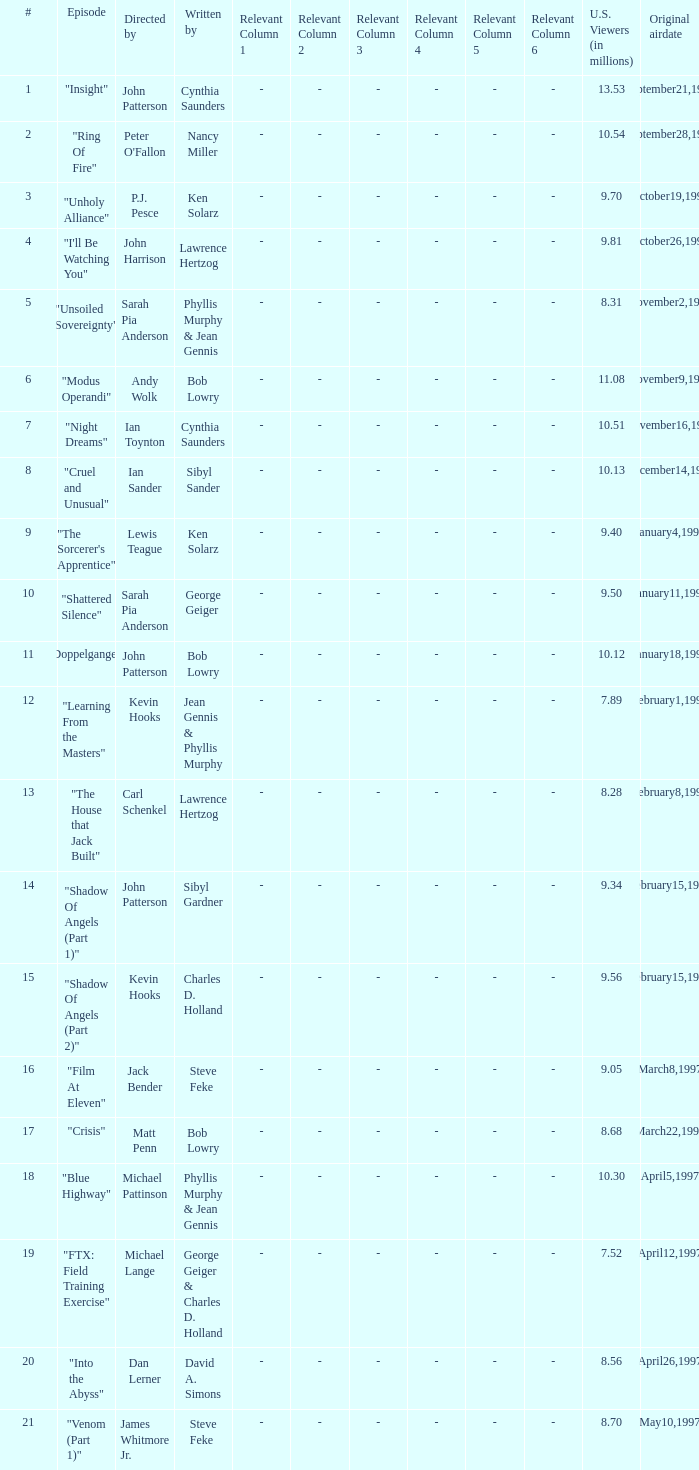Who wrote the episode with 7.52 million US viewers? George Geiger & Charles D. Holland. 